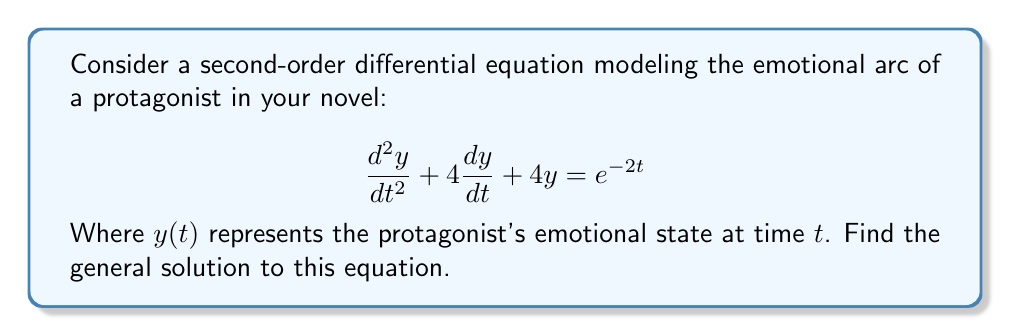What is the answer to this math problem? To solve this second-order differential equation, we'll follow these steps:

1) First, we identify this as a non-homogeneous equation with the form:
   $$ay'' + by' + cy = g(t)$$
   where $a=1$, $b=4$, $c=4$, and $g(t) = e^{-2t}$

2) We start by solving the homogeneous equation:
   $$y'' + 4y' + 4y = 0$$

3) The characteristic equation is:
   $$r^2 + 4r + 4 = 0$$

4) Solving this quadratic equation:
   $$(r + 2)^2 = 0$$
   $r = -2$ (repeated root)

5) The general solution to the homogeneous equation is:
   $$y_h = (C_1 + C_2t)e^{-2t}$$

6) For the particular solution, we use the method of undetermined coefficients. Since $g(t) = e^{-2t}$ and $-2$ is a root of the characteristic equation with multiplicity 2, we try:
   $$y_p = (At^2 + Bt)e^{-2t}$$

7) Substituting this into the original equation and solving for $A$ and $B$:
   $$A = \frac{1}{4}, B = -\frac{1}{2}$$

8) Thus, the particular solution is:
   $$y_p = (\frac{1}{4}t^2 - \frac{1}{2}t)e^{-2t}$$

9) The general solution is the sum of the homogeneous and particular solutions:
   $$y = y_h + y_p = (C_1 + C_2t)e^{-2t} + (\frac{1}{4}t^2 - \frac{1}{2}t)e^{-2t}$$
Answer: The general solution is:

$$y = (C_1 + C_2t + \frac{1}{4}t^2 - \frac{1}{2}t)e^{-2t}$$

Where $C_1$ and $C_2$ are arbitrary constants. 